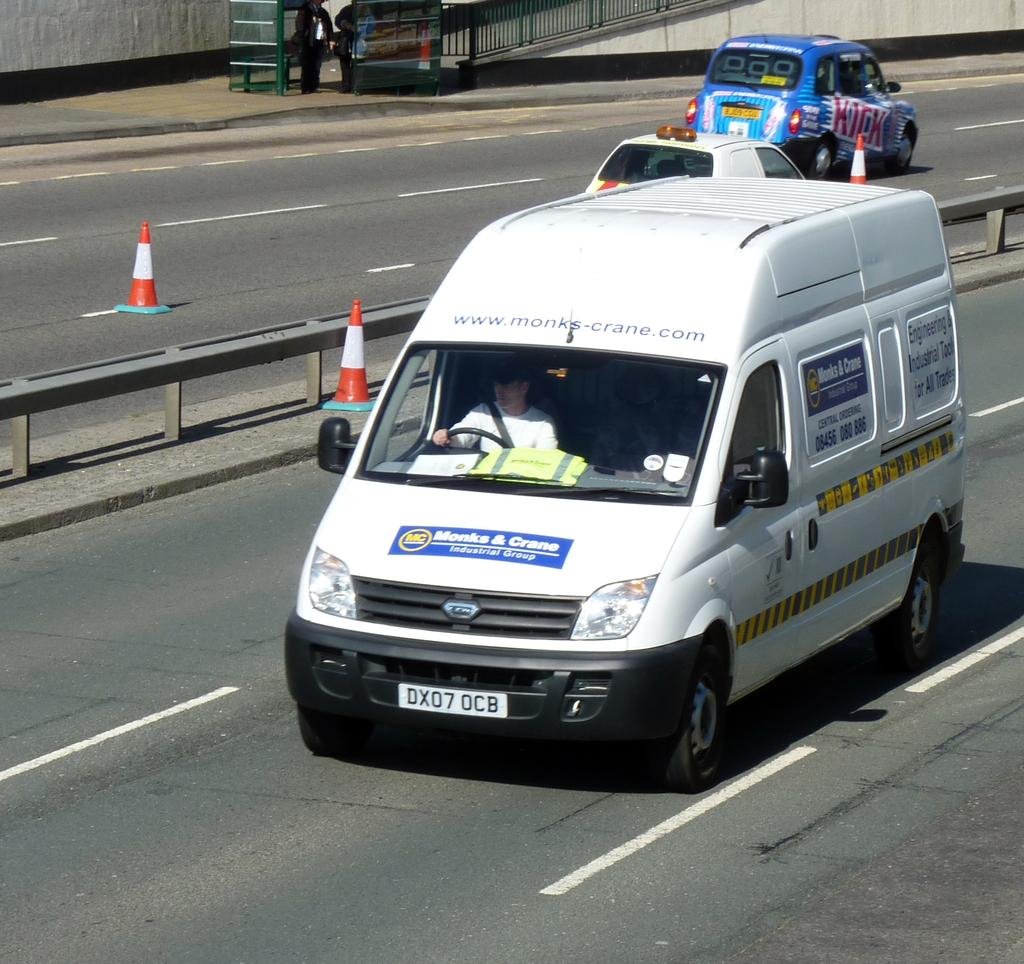<image>
Render a clear and concise summary of the photo. The white van driving down the road has signs for Monks & Crane on it. 